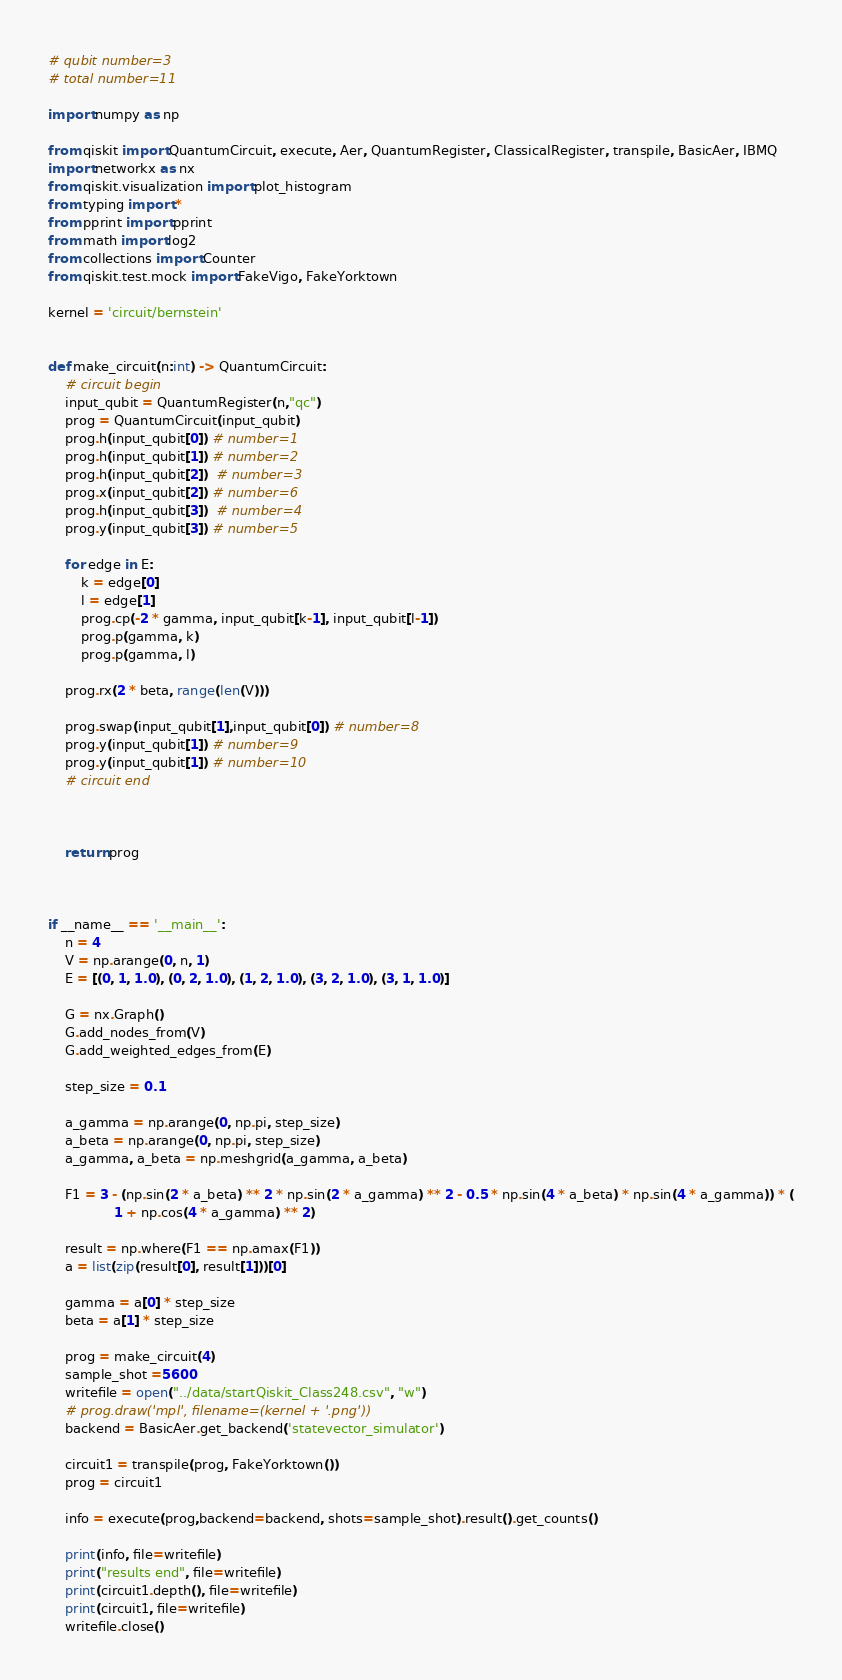<code> <loc_0><loc_0><loc_500><loc_500><_Python_># qubit number=3
# total number=11

import numpy as np

from qiskit import QuantumCircuit, execute, Aer, QuantumRegister, ClassicalRegister, transpile, BasicAer, IBMQ
import networkx as nx
from qiskit.visualization import plot_histogram
from typing import *
from pprint import pprint
from math import log2
from collections import Counter
from qiskit.test.mock import FakeVigo, FakeYorktown

kernel = 'circuit/bernstein'


def make_circuit(n:int) -> QuantumCircuit:
    # circuit begin
    input_qubit = QuantumRegister(n,"qc")
    prog = QuantumCircuit(input_qubit)
    prog.h(input_qubit[0]) # number=1
    prog.h(input_qubit[1]) # number=2
    prog.h(input_qubit[2])  # number=3
    prog.x(input_qubit[2]) # number=6
    prog.h(input_qubit[3])  # number=4
    prog.y(input_qubit[3]) # number=5

    for edge in E:
        k = edge[0]
        l = edge[1]
        prog.cp(-2 * gamma, input_qubit[k-1], input_qubit[l-1])
        prog.p(gamma, k)
        prog.p(gamma, l)

    prog.rx(2 * beta, range(len(V)))

    prog.swap(input_qubit[1],input_qubit[0]) # number=8
    prog.y(input_qubit[1]) # number=9
    prog.y(input_qubit[1]) # number=10
    # circuit end



    return prog



if __name__ == '__main__':
    n = 4
    V = np.arange(0, n, 1)
    E = [(0, 1, 1.0), (0, 2, 1.0), (1, 2, 1.0), (3, 2, 1.0), (3, 1, 1.0)]

    G = nx.Graph()
    G.add_nodes_from(V)
    G.add_weighted_edges_from(E)

    step_size = 0.1

    a_gamma = np.arange(0, np.pi, step_size)
    a_beta = np.arange(0, np.pi, step_size)
    a_gamma, a_beta = np.meshgrid(a_gamma, a_beta)

    F1 = 3 - (np.sin(2 * a_beta) ** 2 * np.sin(2 * a_gamma) ** 2 - 0.5 * np.sin(4 * a_beta) * np.sin(4 * a_gamma)) * (
                1 + np.cos(4 * a_gamma) ** 2)

    result = np.where(F1 == np.amax(F1))
    a = list(zip(result[0], result[1]))[0]

    gamma = a[0] * step_size
    beta = a[1] * step_size

    prog = make_circuit(4)
    sample_shot =5600
    writefile = open("../data/startQiskit_Class248.csv", "w")
    # prog.draw('mpl', filename=(kernel + '.png'))
    backend = BasicAer.get_backend('statevector_simulator')

    circuit1 = transpile(prog, FakeYorktown())
    prog = circuit1

    info = execute(prog,backend=backend, shots=sample_shot).result().get_counts()

    print(info, file=writefile)
    print("results end", file=writefile)
    print(circuit1.depth(), file=writefile)
    print(circuit1, file=writefile)
    writefile.close()
</code> 